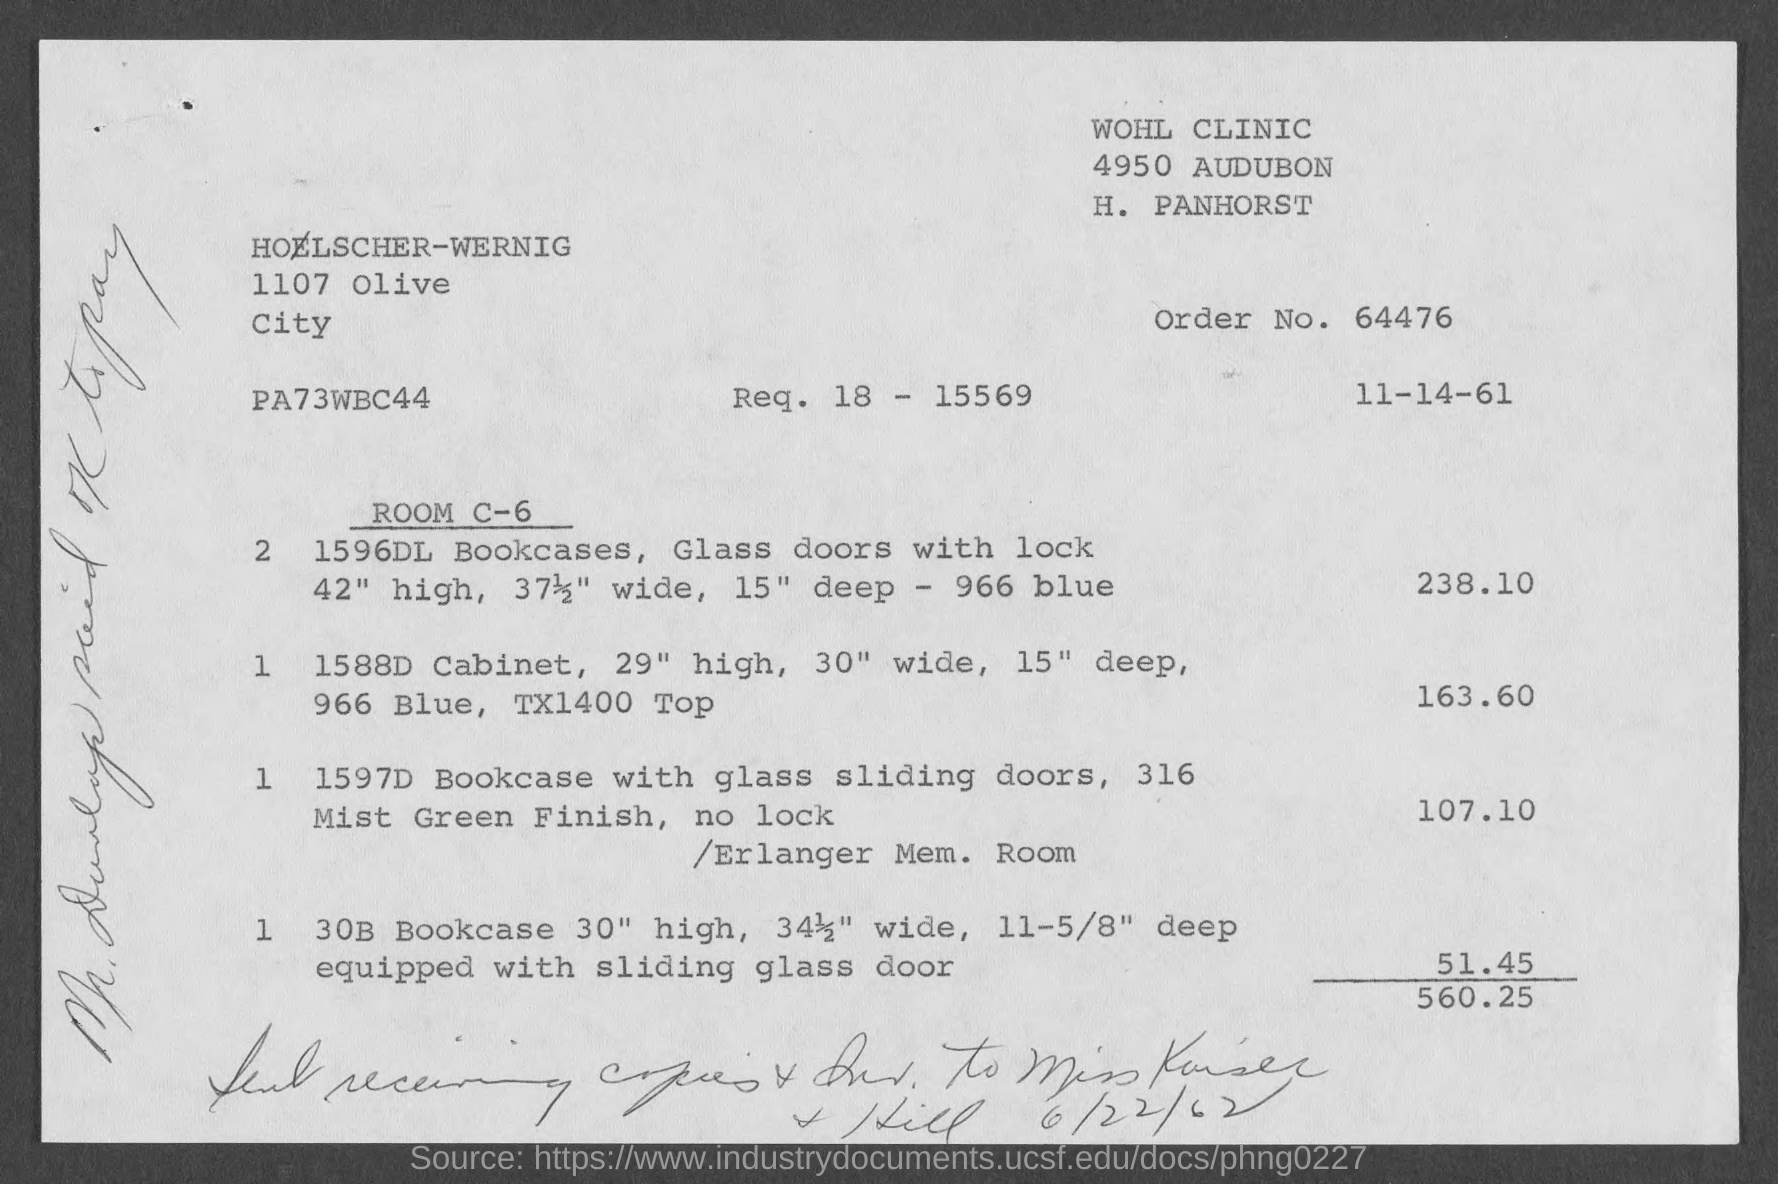Point out several critical features in this image. The order number is 64476... The height of the "1596DL Bookcase" is 42 inches. The value of the "30B Bookcase" is 51.45... The value of the two "1596DL Bookcases" is 238.10. The document, which was found to have a date written on the bottom, bears the inscription '6/22/62.' 